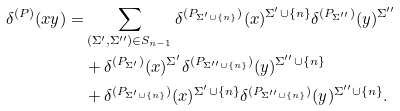<formula> <loc_0><loc_0><loc_500><loc_500>\delta ^ { ( P ) } ( x y ) = & \sum _ { ( \Sigma ^ { \prime } , \Sigma ^ { \prime \prime } ) \in S _ { n - 1 } } \delta ^ { ( P _ { \Sigma ^ { \prime } \cup \{ n \} } ) } ( x ) ^ { \Sigma ^ { \prime } \cup \{ n \} } \delta ^ { ( P _ { \Sigma ^ { \prime \prime } } ) } ( y ) ^ { \Sigma ^ { \prime \prime } } \\ & + \delta ^ { ( P _ { \Sigma ^ { \prime } } ) } ( x ) ^ { \Sigma ^ { \prime } } \delta ^ { ( P _ { \Sigma ^ { \prime \prime } \cup \{ n \} } ) } ( y ) ^ { \Sigma ^ { \prime \prime } \cup \{ n \} } \\ & + \delta ^ { ( P _ { \Sigma ^ { \prime } \cup \{ n \} } ) } ( x ) ^ { \Sigma ^ { \prime } \cup \{ n \} } \delta ^ { ( P _ { \Sigma ^ { \prime \prime } \cup \{ n \} } ) } ( y ) ^ { \Sigma ^ { \prime \prime } \cup \{ n \} } .</formula> 